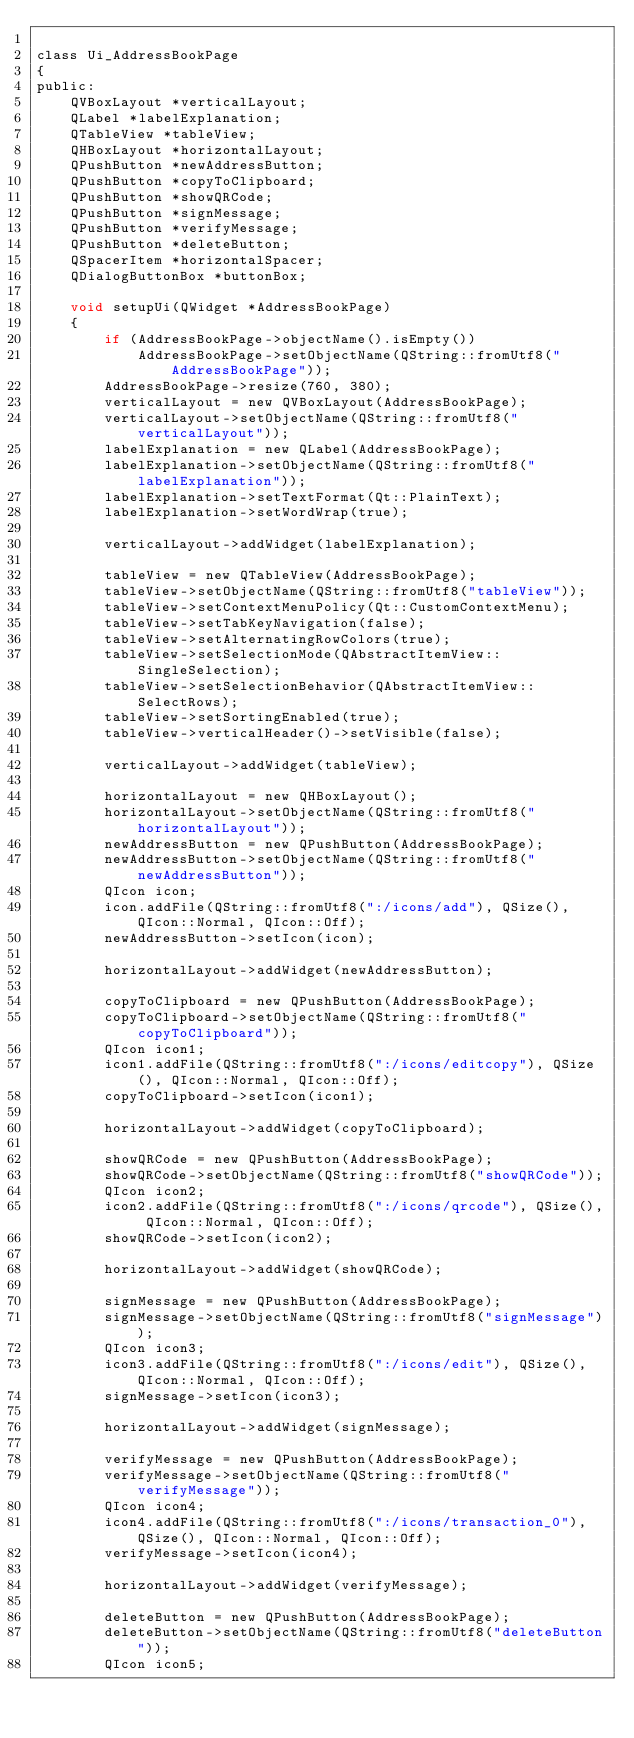Convert code to text. <code><loc_0><loc_0><loc_500><loc_500><_C_>
class Ui_AddressBookPage
{
public:
    QVBoxLayout *verticalLayout;
    QLabel *labelExplanation;
    QTableView *tableView;
    QHBoxLayout *horizontalLayout;
    QPushButton *newAddressButton;
    QPushButton *copyToClipboard;
    QPushButton *showQRCode;
    QPushButton *signMessage;
    QPushButton *verifyMessage;
    QPushButton *deleteButton;
    QSpacerItem *horizontalSpacer;
    QDialogButtonBox *buttonBox;

    void setupUi(QWidget *AddressBookPage)
    {
        if (AddressBookPage->objectName().isEmpty())
            AddressBookPage->setObjectName(QString::fromUtf8("AddressBookPage"));
        AddressBookPage->resize(760, 380);
        verticalLayout = new QVBoxLayout(AddressBookPage);
        verticalLayout->setObjectName(QString::fromUtf8("verticalLayout"));
        labelExplanation = new QLabel(AddressBookPage);
        labelExplanation->setObjectName(QString::fromUtf8("labelExplanation"));
        labelExplanation->setTextFormat(Qt::PlainText);
        labelExplanation->setWordWrap(true);

        verticalLayout->addWidget(labelExplanation);

        tableView = new QTableView(AddressBookPage);
        tableView->setObjectName(QString::fromUtf8("tableView"));
        tableView->setContextMenuPolicy(Qt::CustomContextMenu);
        tableView->setTabKeyNavigation(false);
        tableView->setAlternatingRowColors(true);
        tableView->setSelectionMode(QAbstractItemView::SingleSelection);
        tableView->setSelectionBehavior(QAbstractItemView::SelectRows);
        tableView->setSortingEnabled(true);
        tableView->verticalHeader()->setVisible(false);

        verticalLayout->addWidget(tableView);

        horizontalLayout = new QHBoxLayout();
        horizontalLayout->setObjectName(QString::fromUtf8("horizontalLayout"));
        newAddressButton = new QPushButton(AddressBookPage);
        newAddressButton->setObjectName(QString::fromUtf8("newAddressButton"));
        QIcon icon;
        icon.addFile(QString::fromUtf8(":/icons/add"), QSize(), QIcon::Normal, QIcon::Off);
        newAddressButton->setIcon(icon);

        horizontalLayout->addWidget(newAddressButton);

        copyToClipboard = new QPushButton(AddressBookPage);
        copyToClipboard->setObjectName(QString::fromUtf8("copyToClipboard"));
        QIcon icon1;
        icon1.addFile(QString::fromUtf8(":/icons/editcopy"), QSize(), QIcon::Normal, QIcon::Off);
        copyToClipboard->setIcon(icon1);

        horizontalLayout->addWidget(copyToClipboard);

        showQRCode = new QPushButton(AddressBookPage);
        showQRCode->setObjectName(QString::fromUtf8("showQRCode"));
        QIcon icon2;
        icon2.addFile(QString::fromUtf8(":/icons/qrcode"), QSize(), QIcon::Normal, QIcon::Off);
        showQRCode->setIcon(icon2);

        horizontalLayout->addWidget(showQRCode);

        signMessage = new QPushButton(AddressBookPage);
        signMessage->setObjectName(QString::fromUtf8("signMessage"));
        QIcon icon3;
        icon3.addFile(QString::fromUtf8(":/icons/edit"), QSize(), QIcon::Normal, QIcon::Off);
        signMessage->setIcon(icon3);

        horizontalLayout->addWidget(signMessage);

        verifyMessage = new QPushButton(AddressBookPage);
        verifyMessage->setObjectName(QString::fromUtf8("verifyMessage"));
        QIcon icon4;
        icon4.addFile(QString::fromUtf8(":/icons/transaction_0"), QSize(), QIcon::Normal, QIcon::Off);
        verifyMessage->setIcon(icon4);

        horizontalLayout->addWidget(verifyMessage);

        deleteButton = new QPushButton(AddressBookPage);
        deleteButton->setObjectName(QString::fromUtf8("deleteButton"));
        QIcon icon5;</code> 